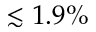<formula> <loc_0><loc_0><loc_500><loc_500>\lesssim 1 . 9 \%</formula> 